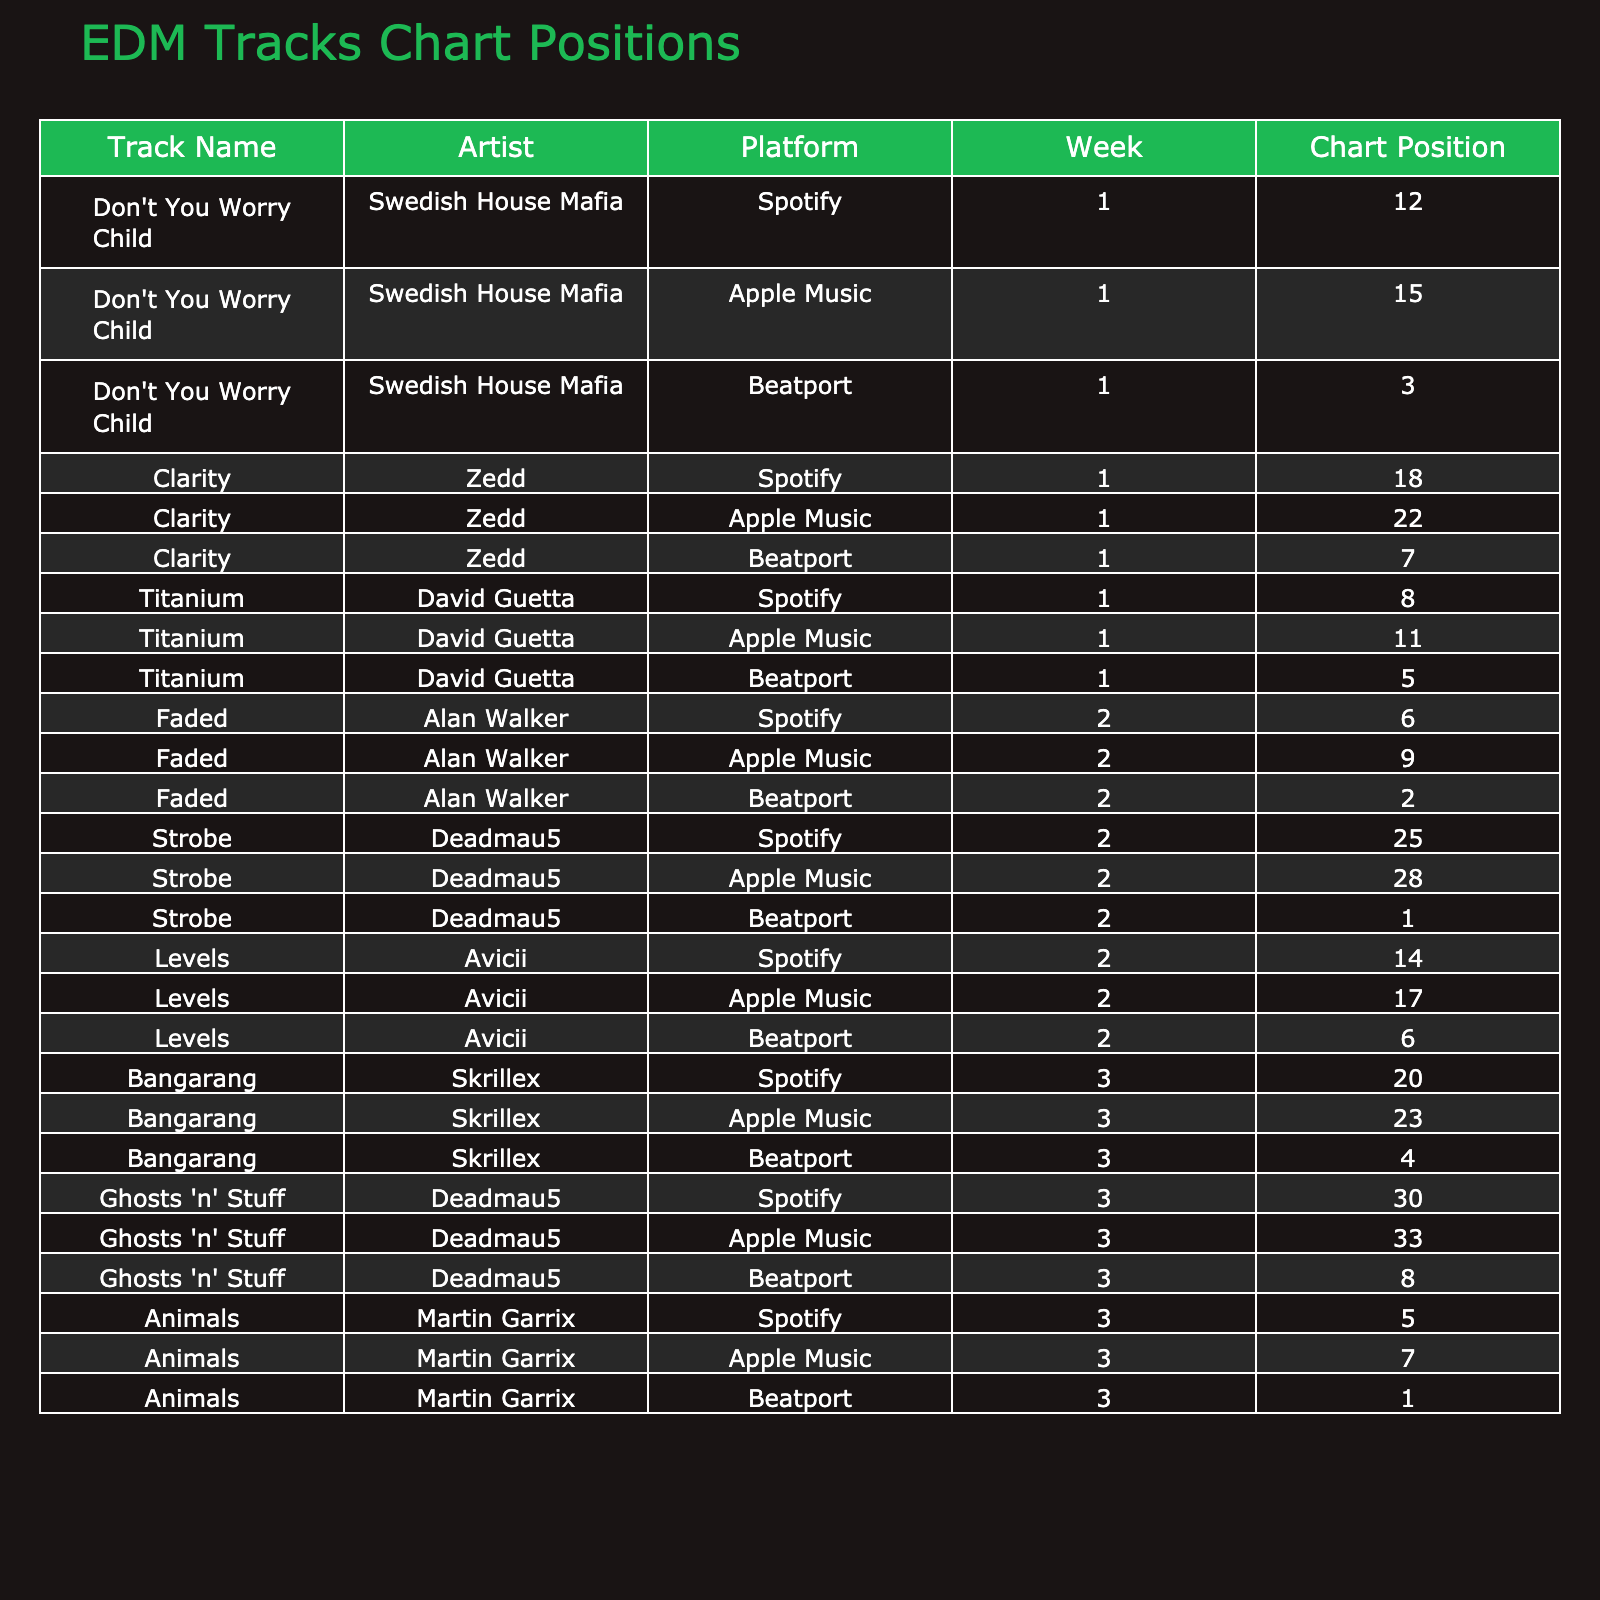What is the highest chart position for "Faded" across all platforms? "Faded" has a chart position of 2 on Beatport, which is the highest compared to its positions of 6 on Spotify and 9 on Apple Music.
Answer: 2 Which track achieved the top chart position on Beatport? "Strobe" reached the highest chart position of 1 on Beatport, as indicated in its entry.
Answer: "Strobe" How many tracks had a Spotify chart position below 10? The tracks with Spotify positions below 10 are "Titanium" (8), "Faded" (6), "Animals" (5), resulting in a total of 3 tracks.
Answer: 3 Is there any track that performed better on Beatport than on both Spotify and Apple Music? "Animals" is such a track, ranking 1 on Beatport, while it ranks 5 on Spotify and 7 on Apple Music, confirming it performed better on Beatport than both other platforms.
Answer: Yes What is the average chart position of "Don't You Worry Child" across all platforms? The positions of "Don't You Worry Child" are 12 on Spotify, 15 on Apple Music, and 3 on Beatport. Summing these positions gives 30, and dividing by 3 results in an average of 10.
Answer: 10 Which artist has a track that reached the highest position on Spotify? Alan Walker’s track "Faded" reached position 6 on Spotify, which is the highest position among all tracks listed.
Answer: Alan Walker How many tracks had a chart position of 25 or higher on Spotify? There are two tracks with a position of 25 or higher on Spotify: "Strobe" (25) and "Ghosts 'n' Stuff" (30), totaling 2 tracks.
Answer: 2 What is the difference between the highest and lowest chart position for "Clarity" on the platforms? "Clarity" has a highest position of 7 on Beatport and a lowest of 22 on Apple Music. The difference is 22 - 7 = 15.
Answer: 15 Identify the track with the most consistent positions across the three platforms. "Titanium" by David Guetta has positions of 8, 11, and 5 across Spotify, Apple Music, and Beatport respectively, showing relatively close ranks compared to others, which often fluctuate more widely.
Answer: "Titanium" Which platform had the lowest chart position for "Bangarang"? On Spotify, "Bangarang" has a position of 20, which is lower than its positions of 23 on Apple Music and 4 on Beatport.
Answer: Spotify 